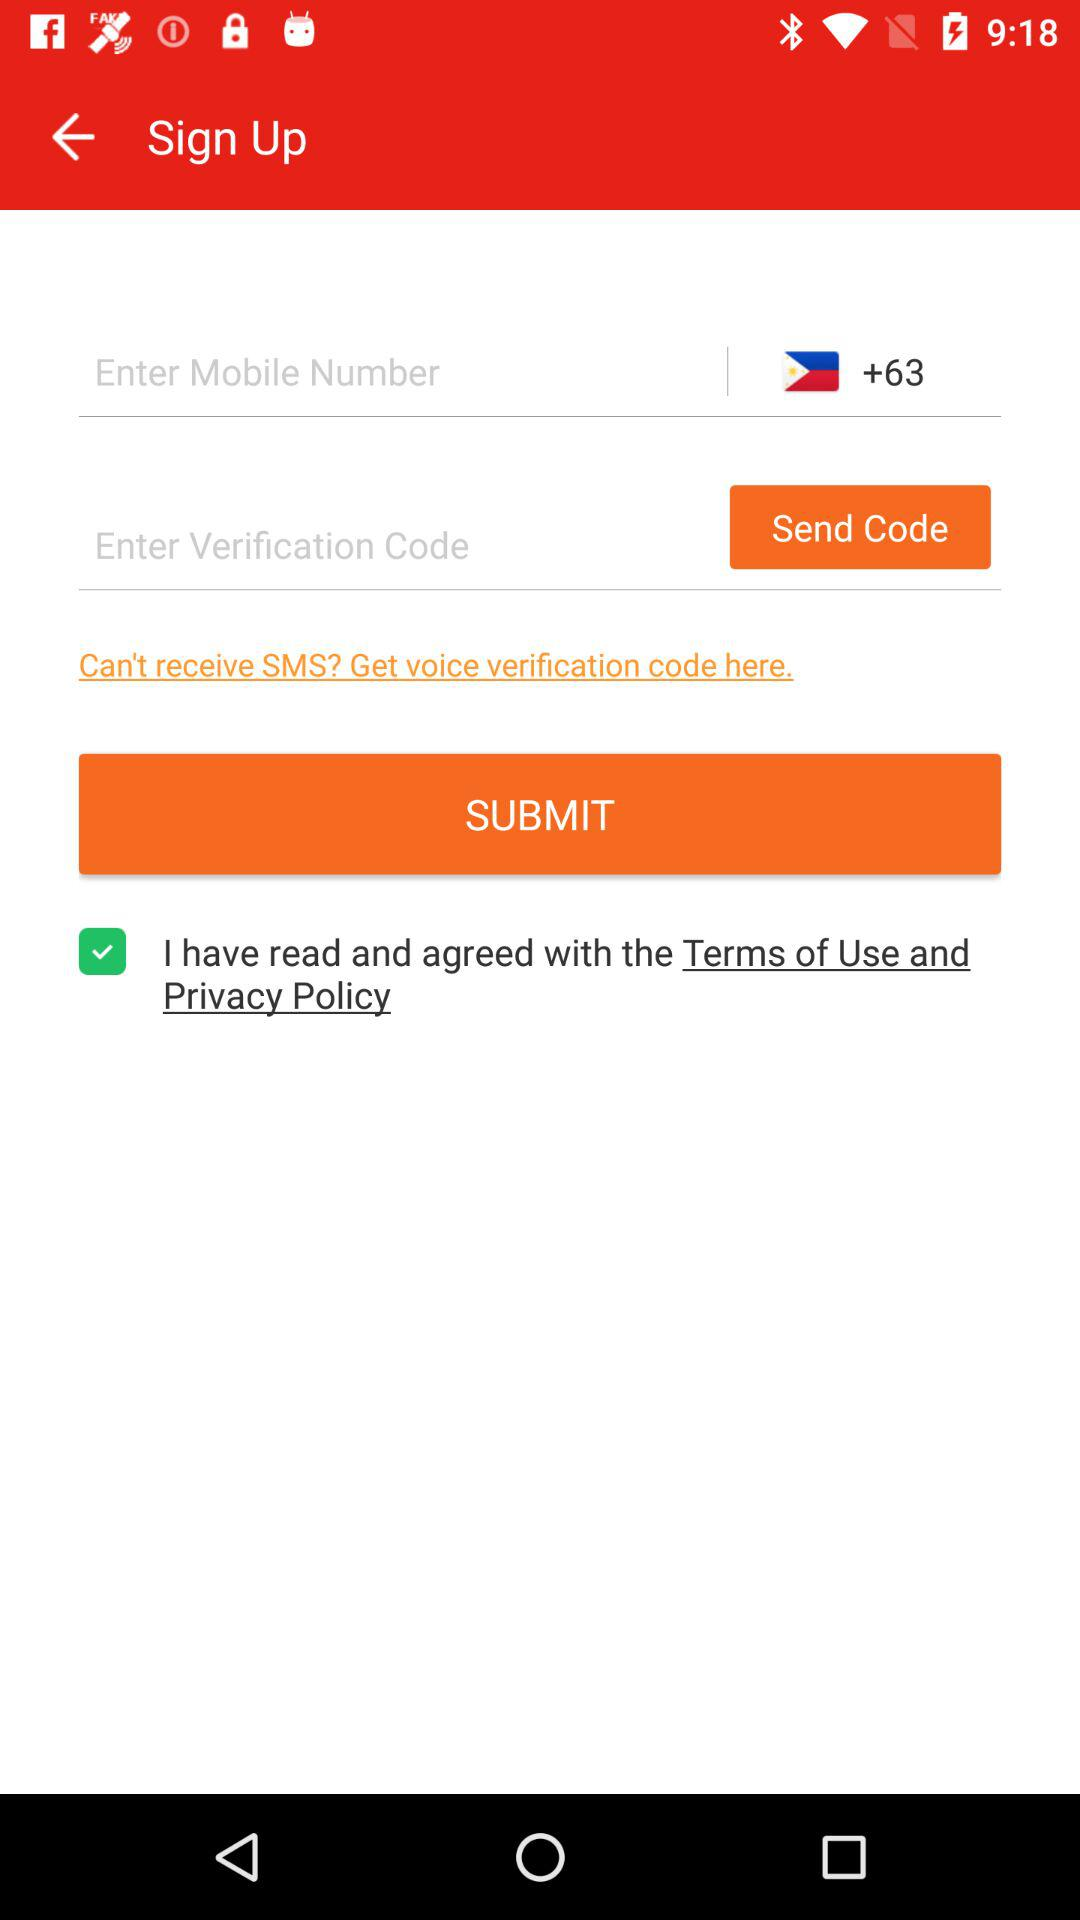What is the country code? The country code is +63. 